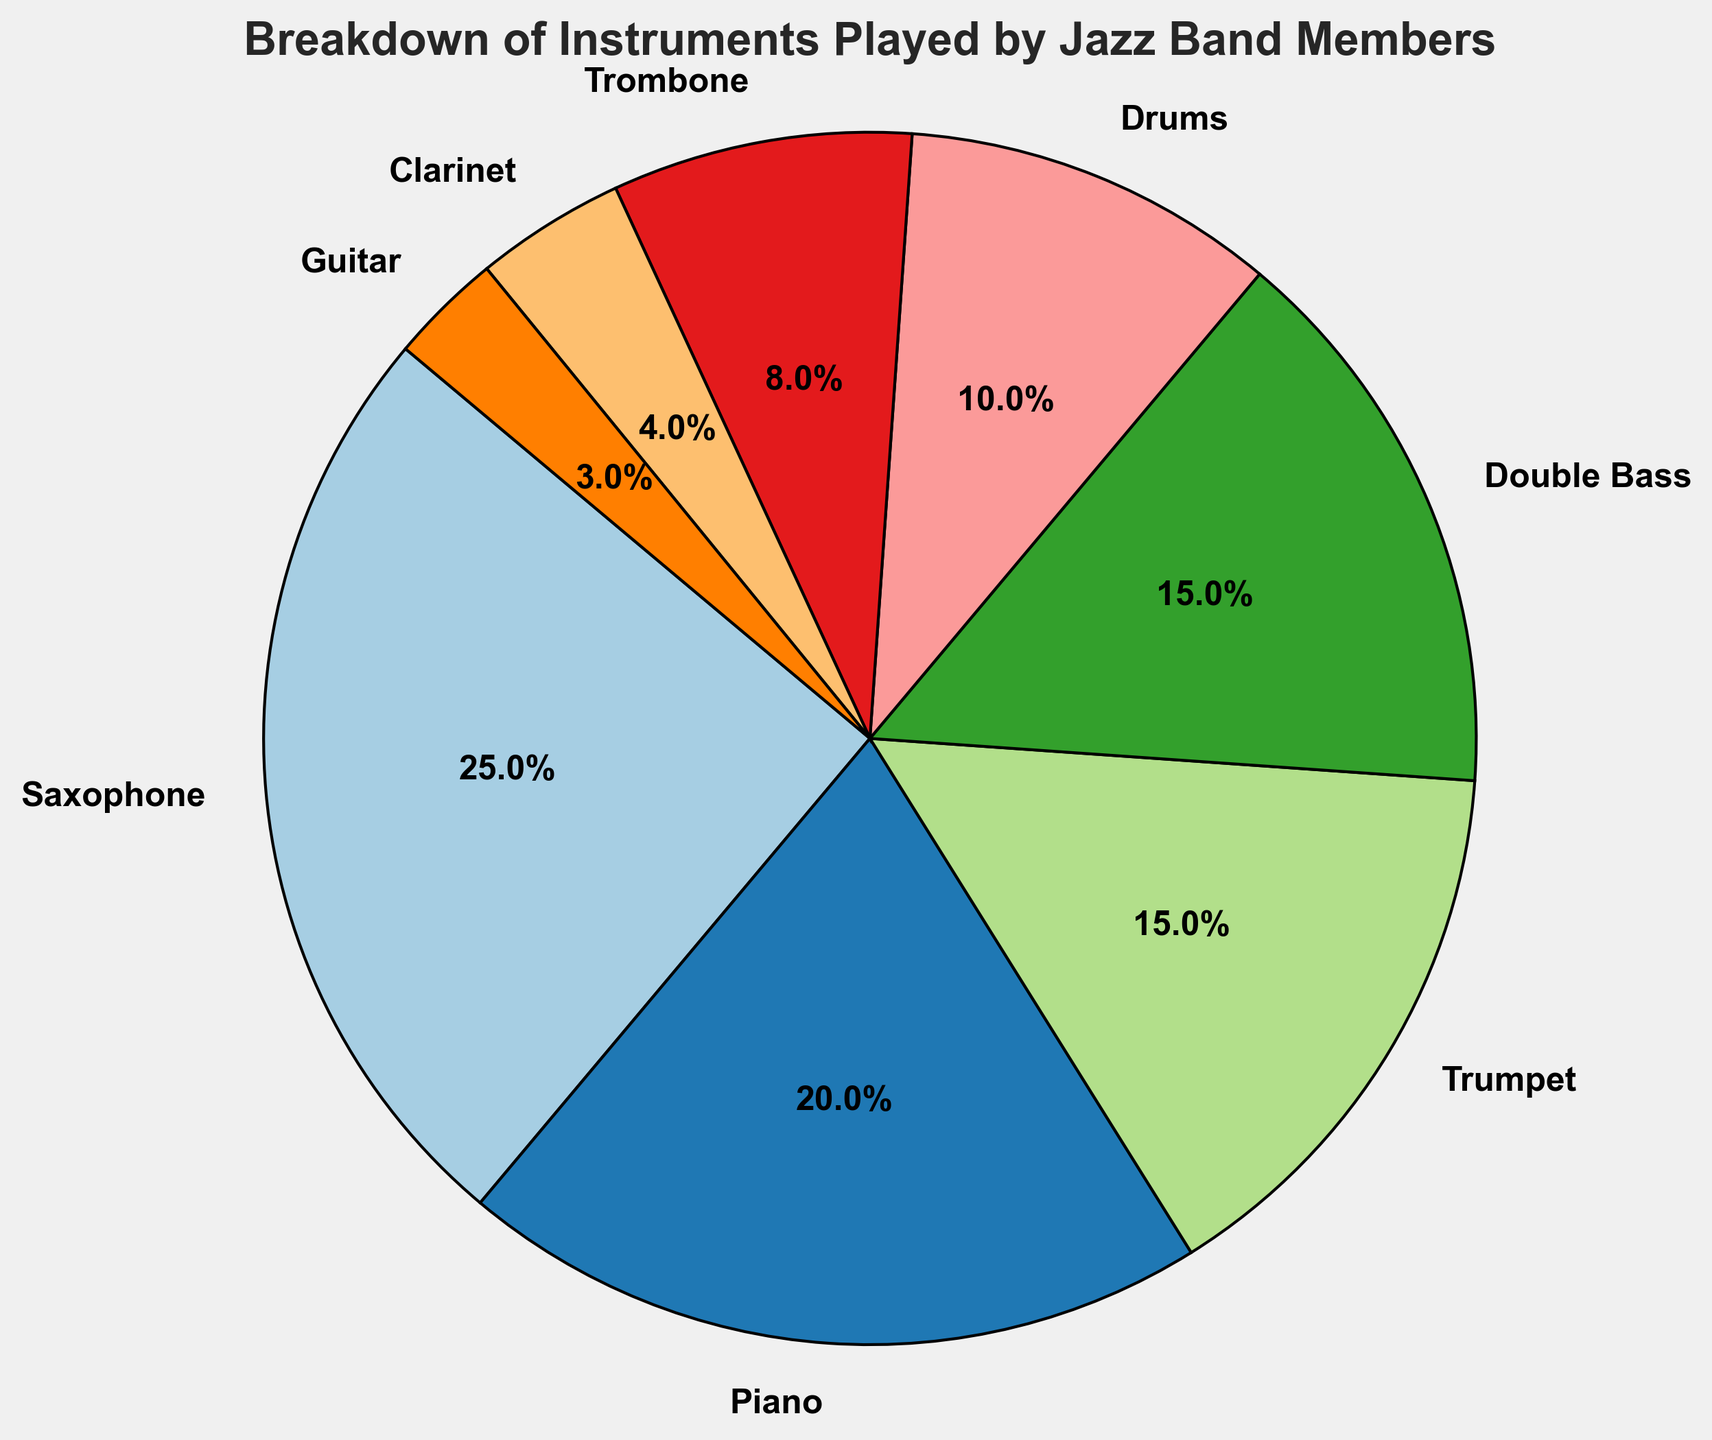What's the most played instrument in the jazz band? The most played instrument is the one with the highest percentage in the pie chart. The Saxophone has the highest percentage of 25%.
Answer: Saxophone Which instrument has the smallest representation in the jazz band? The instrument with the smallest representation will be the one with the smallest wedge or smallest percentage. Guitar has the smallest percentage of 3%.
Answer: Guitar What is the combined percentage of Saxophone, Piano, and Trumpet players? Add the percentages of Saxophone (25%), Piano (20%), and Trumpet (15%). The combined percentage is 25 + 20 + 15 = 60.
Answer: 60% Do Drums or Trombone players make up a larger portion of the band? Compare the percentage of Drums (10%) with Trombone (8%). Drums have a larger percentage.
Answer: Drums Are there more Double Bass players or Clarinet players, and by how much? Compare the percentages of Double Bass (15%) and Clarinet (4%). Subtract the smaller percentage from the larger percentage: 15 - 4 = 11. There are 11% more Double Bass players than Clarinet players.
Answer: Double Bass, by 11% What is the total percentage of band members playing wind instruments (Saxophone, Trumpet, Trombone, Clarinet)? Add the percentages of Saxophone (25%), Trumpet (15%), Trombone (8%), and Clarinet (4%). The total is 25 + 15 + 8 + 4 = 52.
Answer: 52% Is the percentage of Piano players greater than the sum of Trombone and Guitar players? Compare the percentage of Piano (20%) with the combined percentage of Trombone (8%) and Guitar (3%). 20% is greater than 8 + 3 = 11%.
Answer: Yes Do the Saxophone and Drums together make up more or less than 35% of the band? Add the percentages of Saxophone (25%) and Drums (10%). 25 + 10 = 35, which is exactly 35%.
Answer: Exactly 35% What's the percentage difference between the most played instrument and the least played instrument? Subtract the smallest percentage (Guitar, 3%) from the largest percentage (Saxophone, 25%). 25 - 3 = 22.
Answer: 22% What is the sum of the percentages of the two least common instruments? Add the percentages of Clarinet (4%) and Guitar (3%). The sum is 4 + 3 = 7.
Answer: 7% 